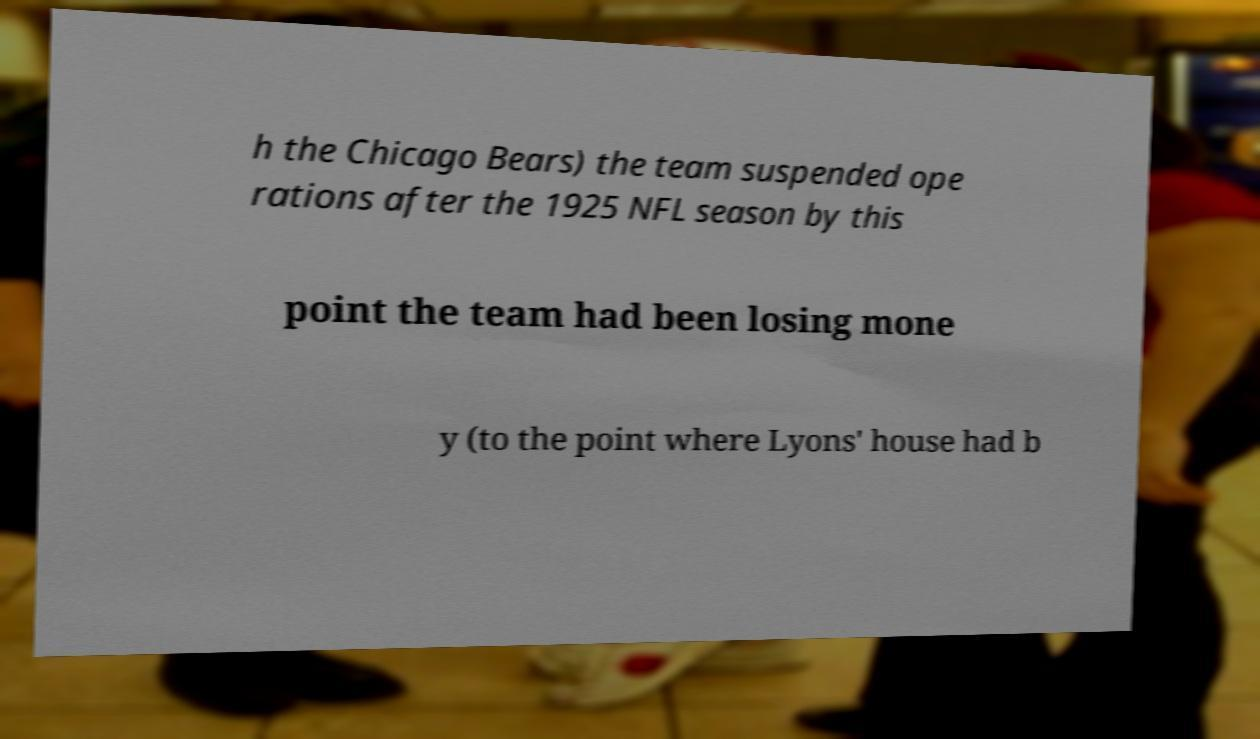Please read and relay the text visible in this image. What does it say? h the Chicago Bears) the team suspended ope rations after the 1925 NFL season by this point the team had been losing mone y (to the point where Lyons' house had b 